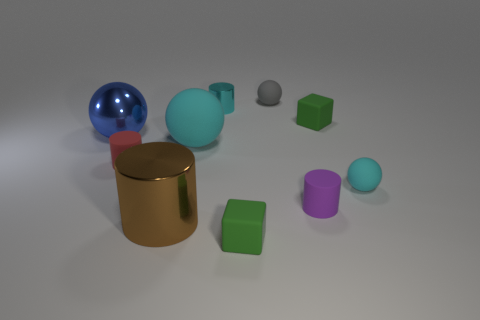What number of matte objects are brown cubes or small red things?
Offer a very short reply. 1. There is another small thing that is the same color as the small metallic thing; what is its material?
Keep it short and to the point. Rubber. Do the purple matte cylinder and the blue object have the same size?
Make the answer very short. No. What number of things are tiny green shiny cubes or things that are to the left of the brown metallic object?
Your answer should be very brief. 2. What material is the red cylinder that is the same size as the purple rubber cylinder?
Your response must be concise. Rubber. There is a cylinder that is both left of the tiny cyan cylinder and behind the big metal cylinder; what is its material?
Your answer should be very brief. Rubber. There is a matte cylinder right of the gray object; are there any tiny gray rubber objects that are in front of it?
Make the answer very short. No. There is a sphere that is both on the right side of the red cylinder and behind the big cyan matte object; how big is it?
Your response must be concise. Small. What number of green things are either metallic balls or small blocks?
Your response must be concise. 2. What is the shape of the blue metal thing that is the same size as the brown cylinder?
Make the answer very short. Sphere. 